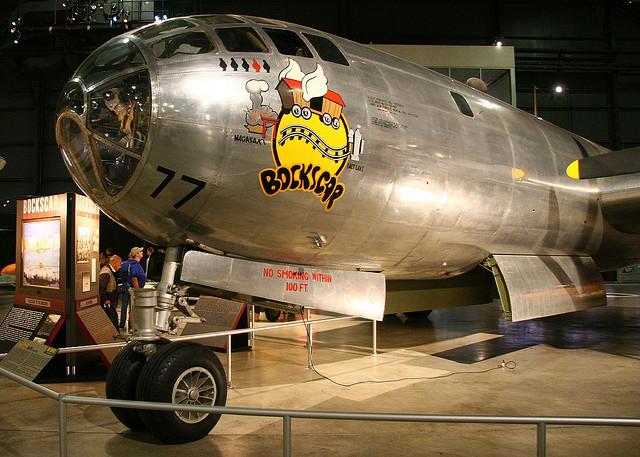What is the names of the plane?
Be succinct. Bockscar. What is the color of the plane?
Give a very brief answer. Silver. Is this a good place to light up?
Short answer required. No. 